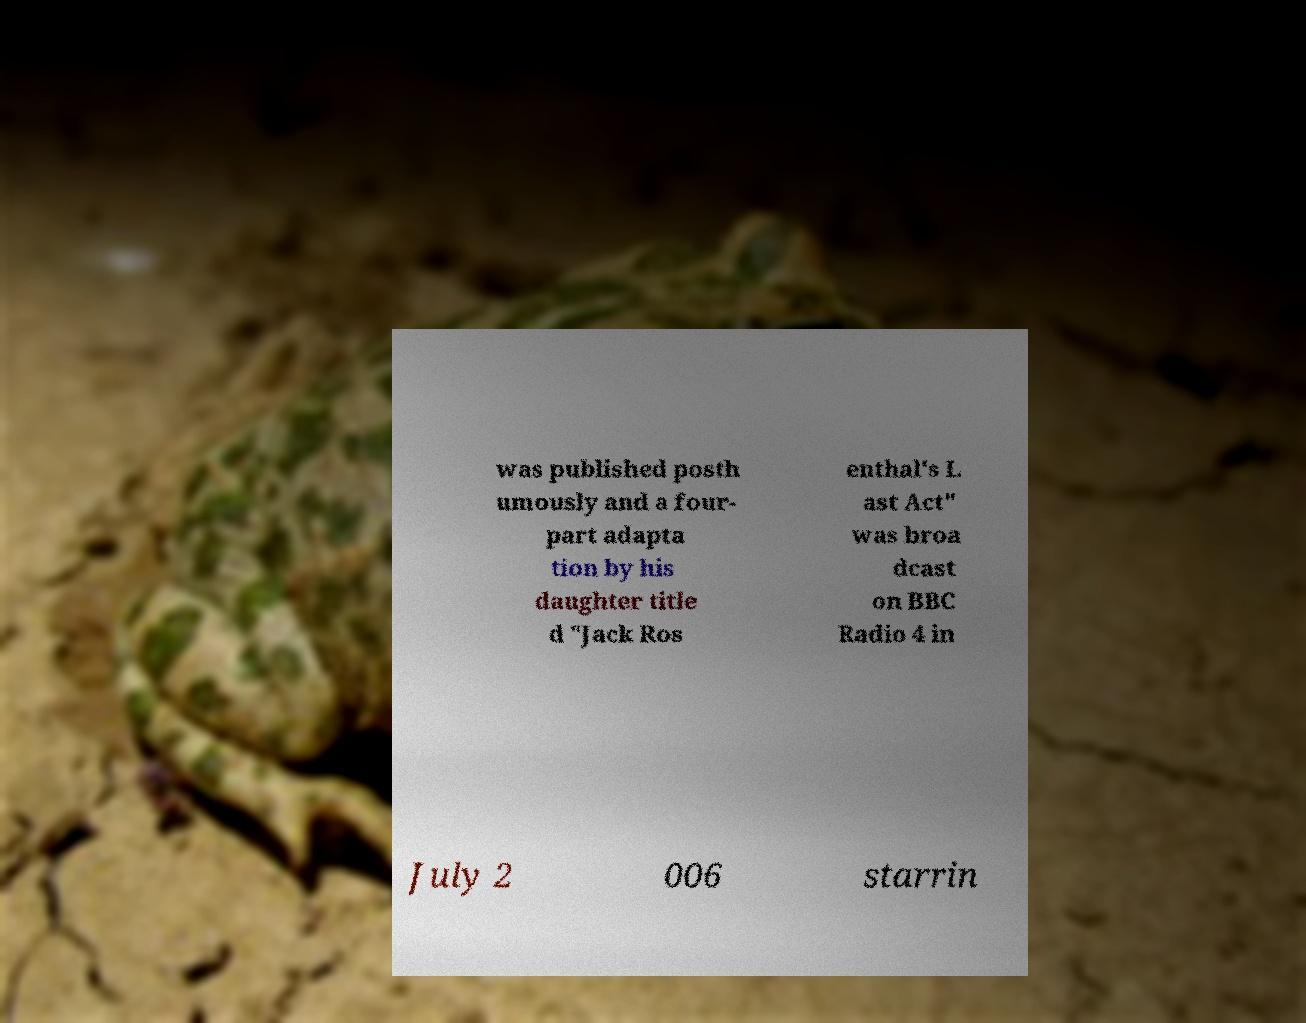Could you extract and type out the text from this image? was published posth umously and a four- part adapta tion by his daughter title d "Jack Ros enthal's L ast Act" was broa dcast on BBC Radio 4 in July 2 006 starrin 